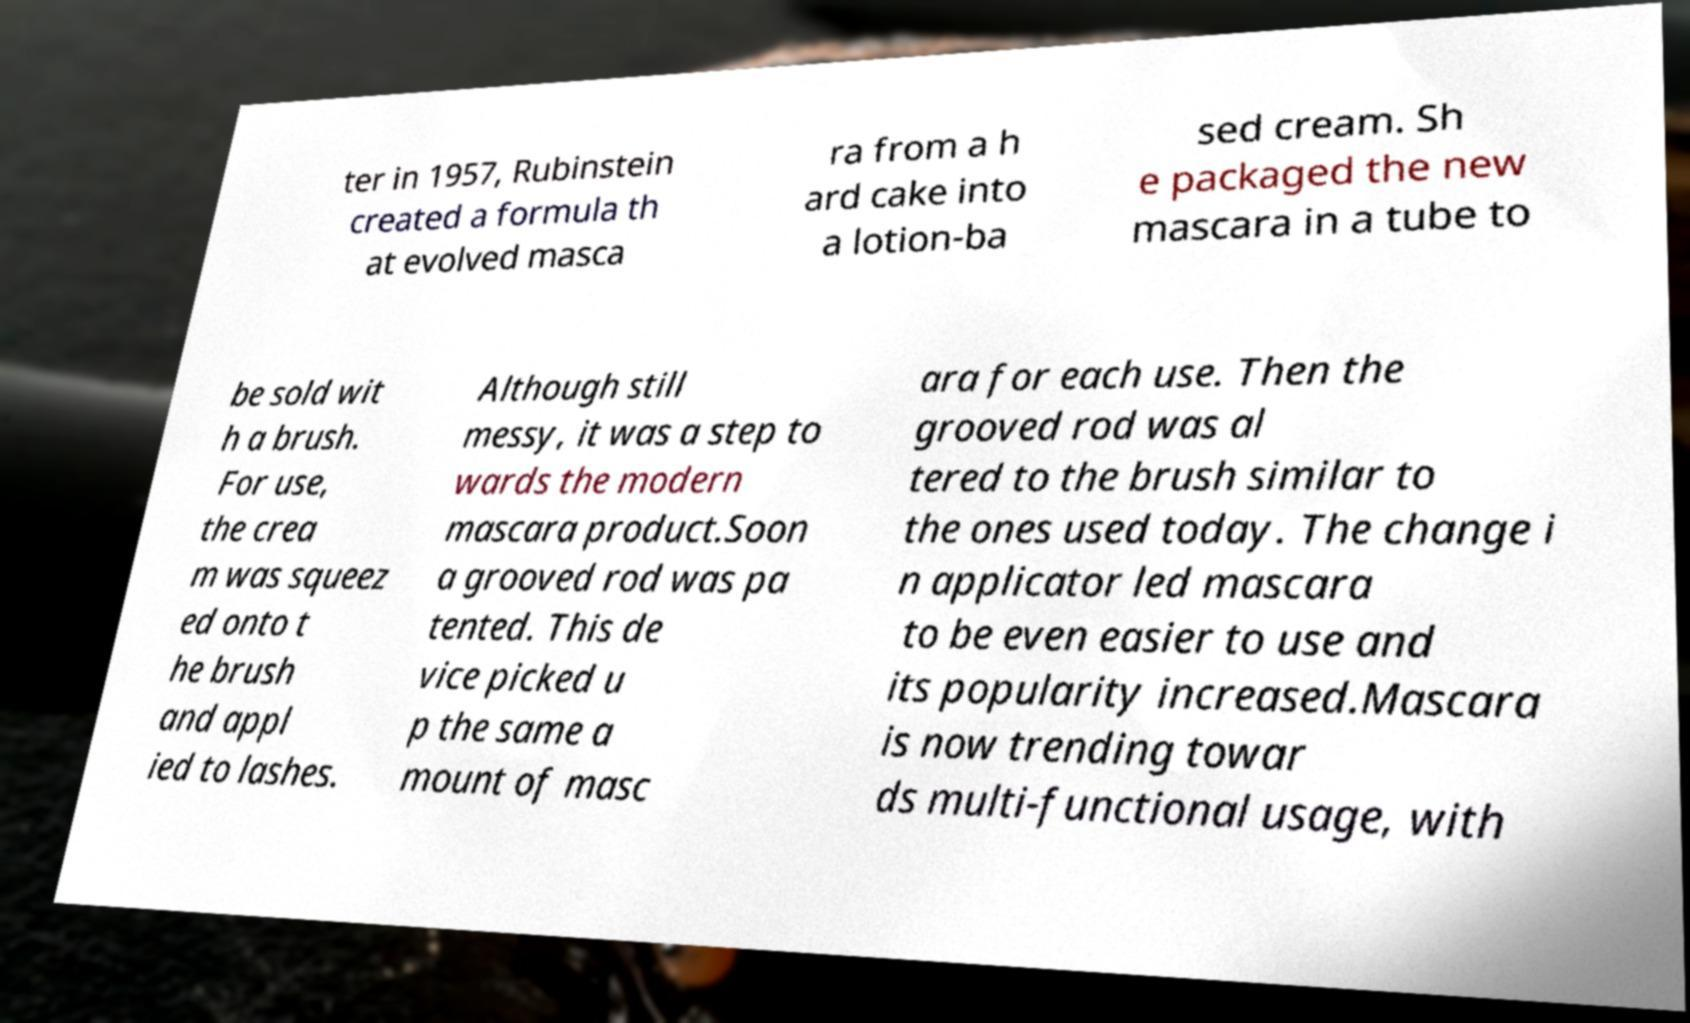For documentation purposes, I need the text within this image transcribed. Could you provide that? ter in 1957, Rubinstein created a formula th at evolved masca ra from a h ard cake into a lotion-ba sed cream. Sh e packaged the new mascara in a tube to be sold wit h a brush. For use, the crea m was squeez ed onto t he brush and appl ied to lashes. Although still messy, it was a step to wards the modern mascara product.Soon a grooved rod was pa tented. This de vice picked u p the same a mount of masc ara for each use. Then the grooved rod was al tered to the brush similar to the ones used today. The change i n applicator led mascara to be even easier to use and its popularity increased.Mascara is now trending towar ds multi-functional usage, with 